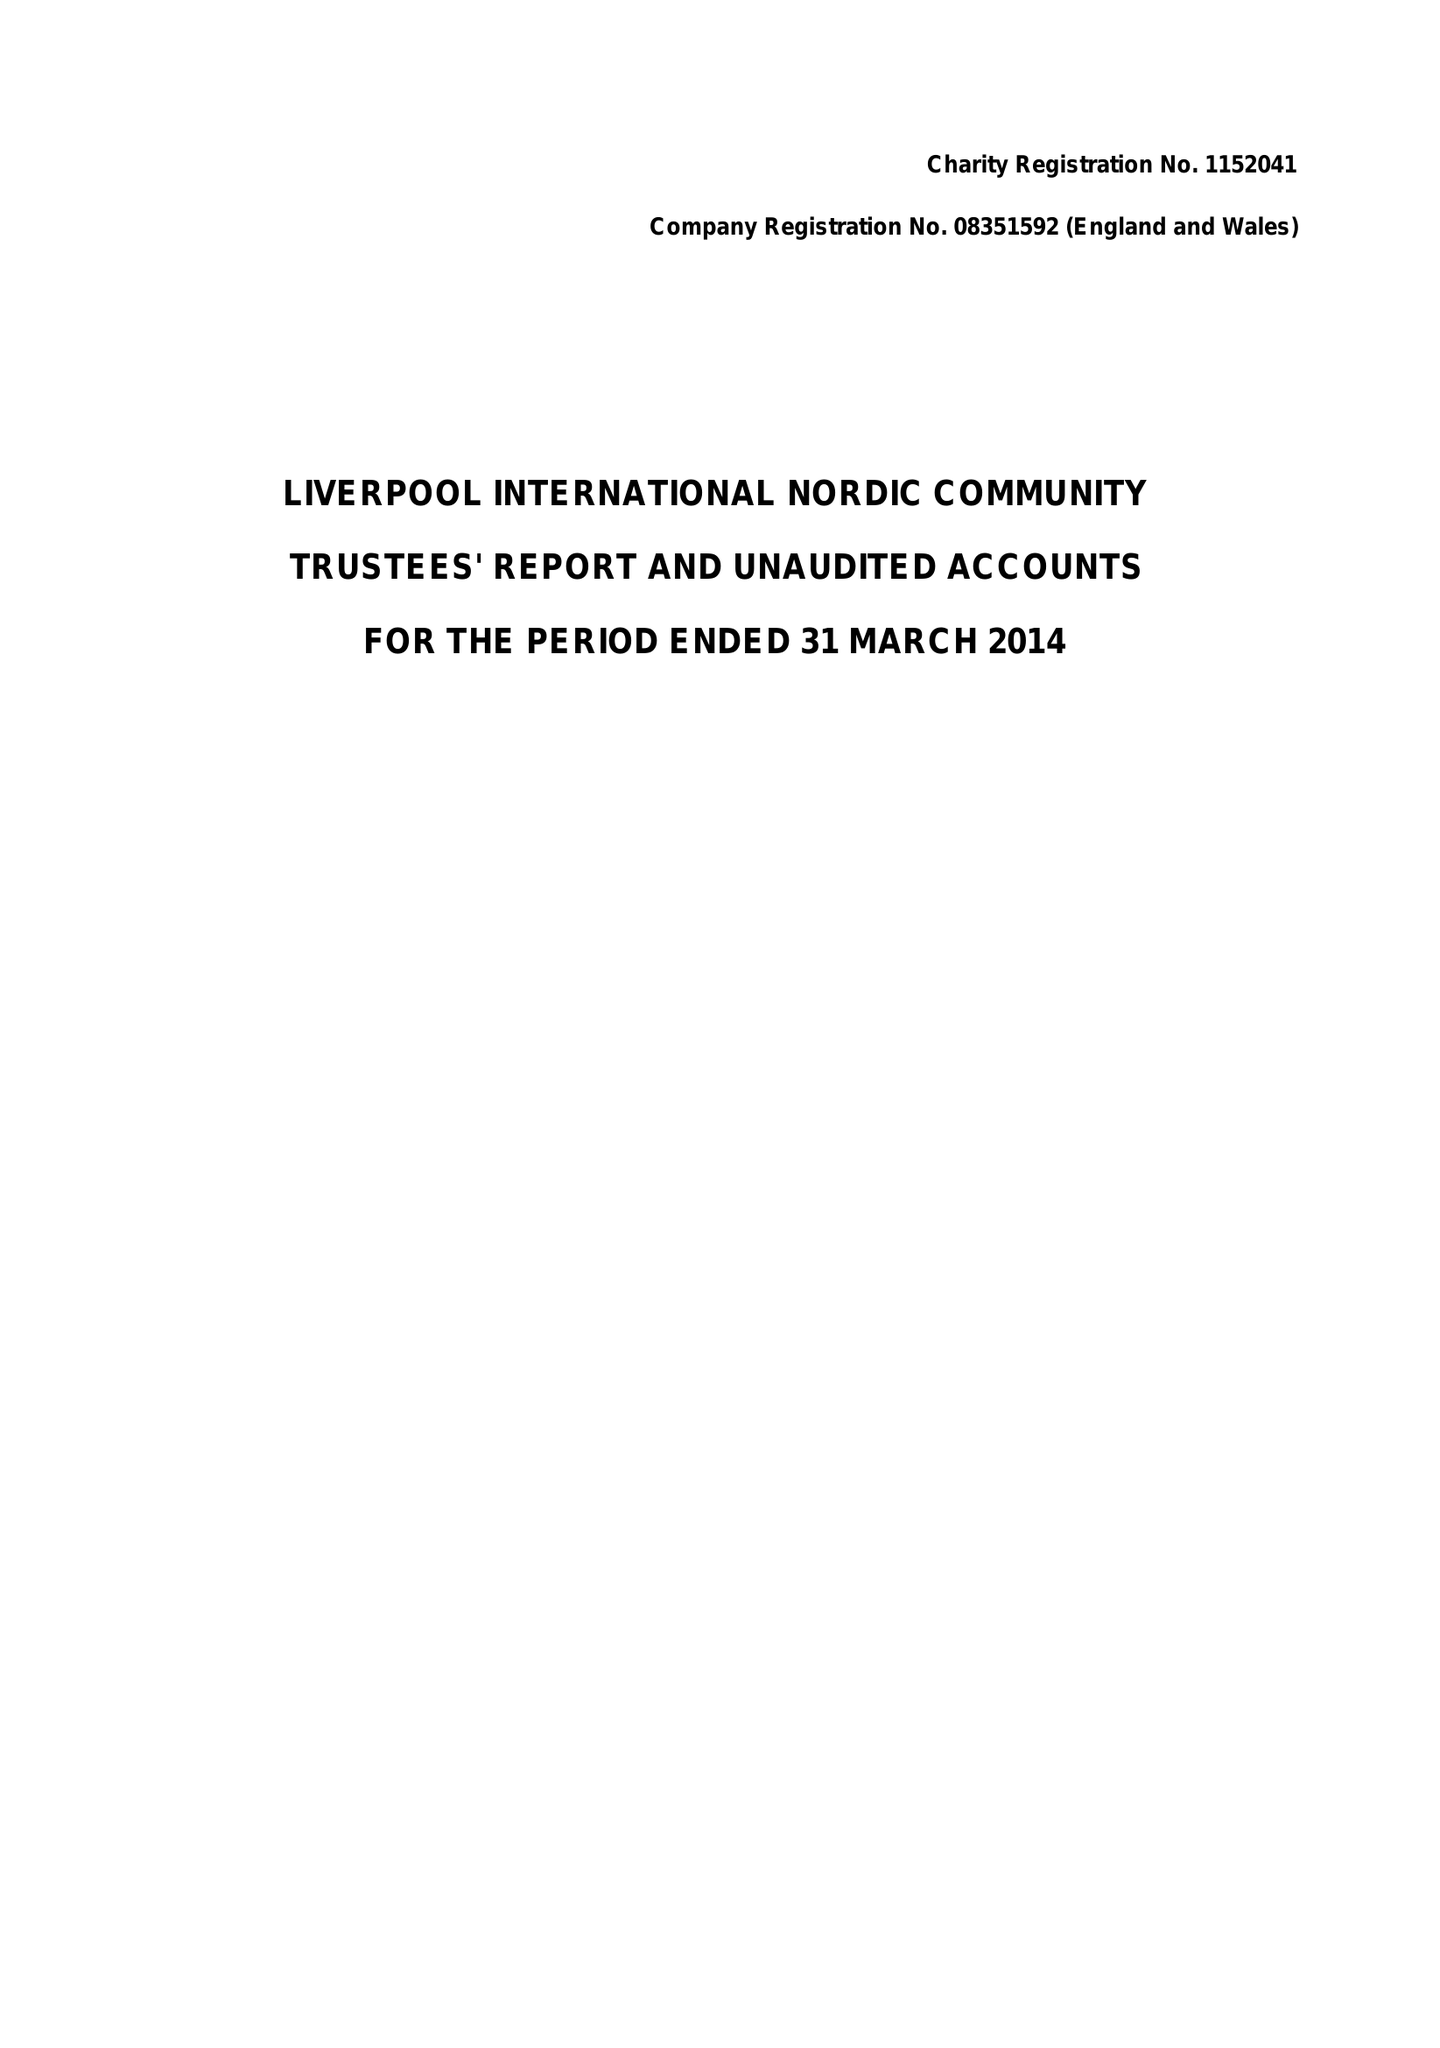What is the value for the spending_annually_in_british_pounds?
Answer the question using a single word or phrase. 34019.00 